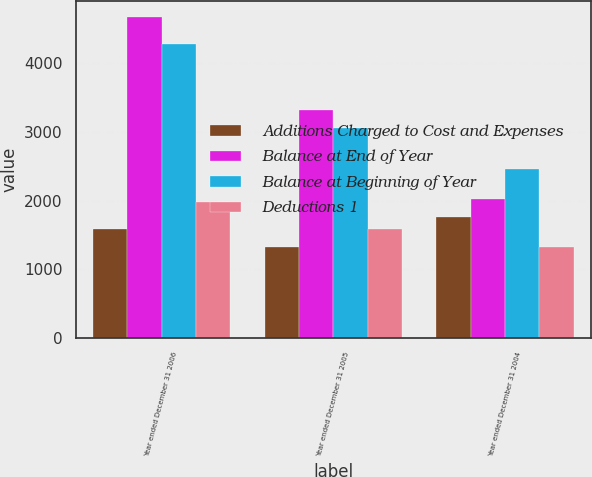Convert chart. <chart><loc_0><loc_0><loc_500><loc_500><stacked_bar_chart><ecel><fcel>Year ended December 31 2006<fcel>Year ended December 31 2005<fcel>Year ended December 31 2004<nl><fcel>Additions Charged to Cost and Expenses<fcel>1591<fcel>1334<fcel>1765<nl><fcel>Balance at End of Year<fcel>4670<fcel>3317<fcel>2026<nl><fcel>Balance at Beginning of Year<fcel>4283<fcel>3060<fcel>2457<nl><fcel>Deductions 1<fcel>1978<fcel>1591<fcel>1334<nl></chart> 